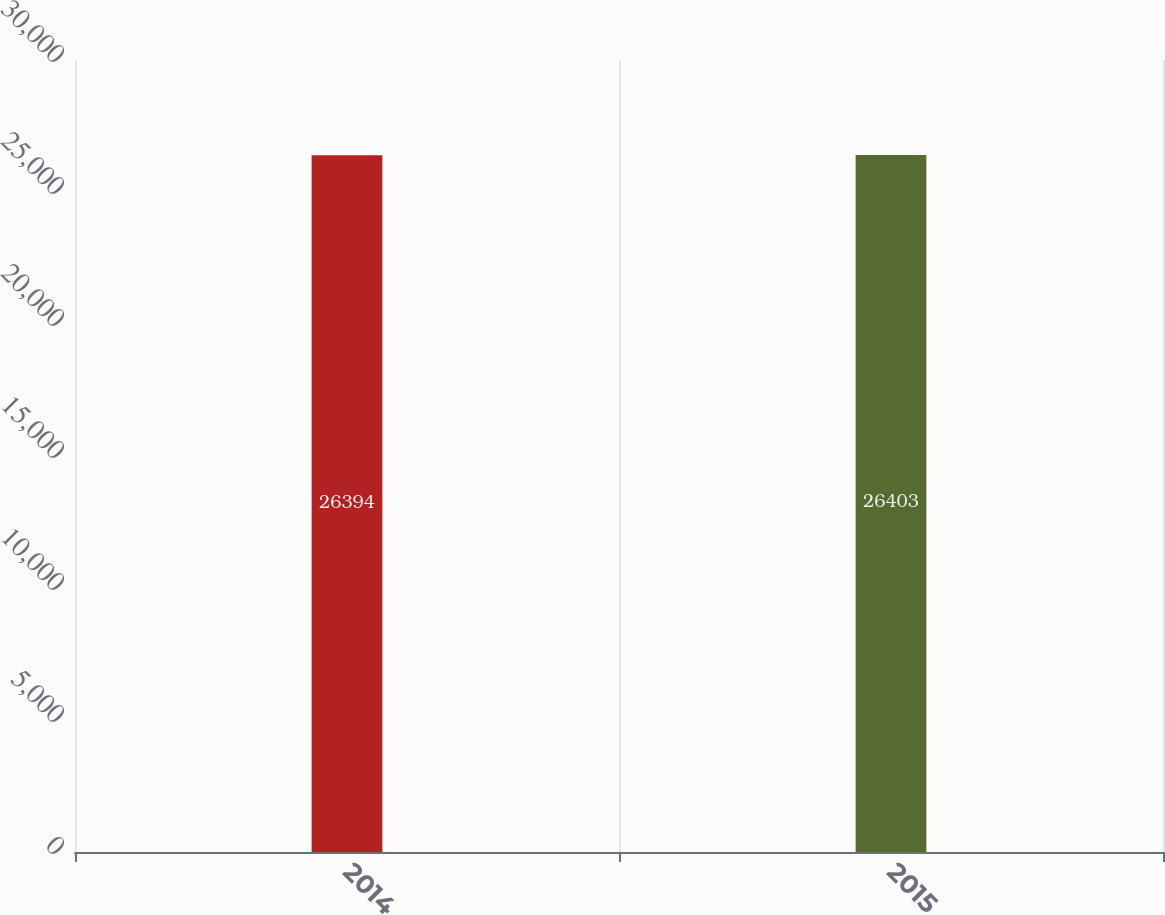Convert chart. <chart><loc_0><loc_0><loc_500><loc_500><bar_chart><fcel>2014<fcel>2015<nl><fcel>26394<fcel>26403<nl></chart> 